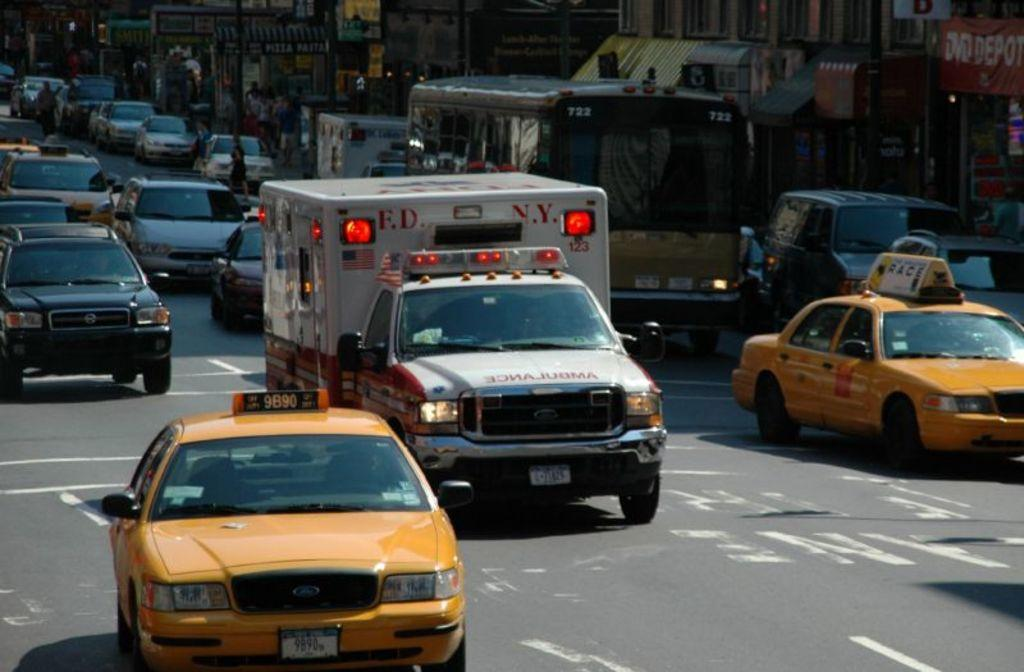<image>
Render a clear and concise summary of the photo. traffic in an urban street with an FDNY ambulance in the middle 